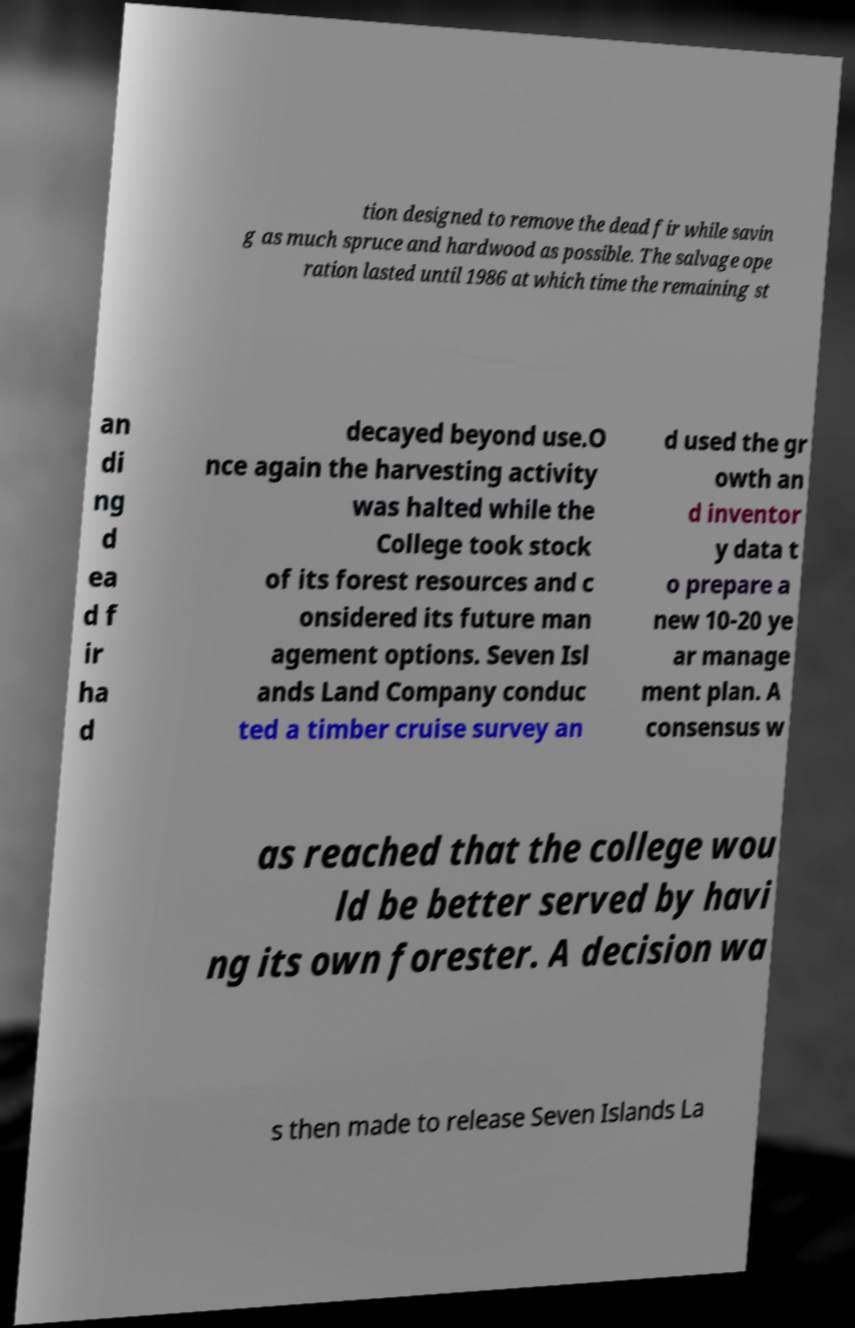For documentation purposes, I need the text within this image transcribed. Could you provide that? tion designed to remove the dead fir while savin g as much spruce and hardwood as possible. The salvage ope ration lasted until 1986 at which time the remaining st an di ng d ea d f ir ha d decayed beyond use.O nce again the harvesting activity was halted while the College took stock of its forest resources and c onsidered its future man agement options. Seven Isl ands Land Company conduc ted a timber cruise survey an d used the gr owth an d inventor y data t o prepare a new 10-20 ye ar manage ment plan. A consensus w as reached that the college wou ld be better served by havi ng its own forester. A decision wa s then made to release Seven Islands La 